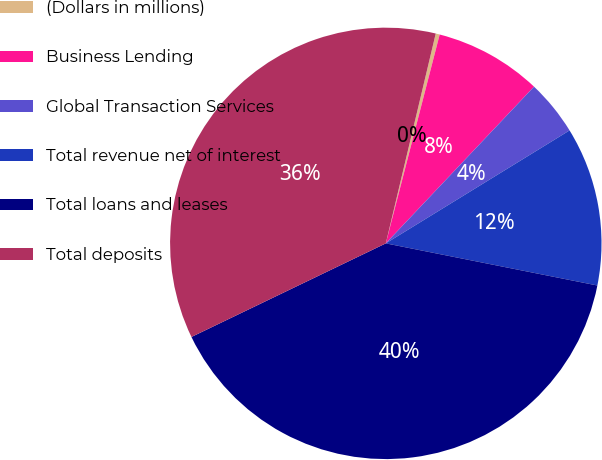Convert chart to OTSL. <chart><loc_0><loc_0><loc_500><loc_500><pie_chart><fcel>(Dollars in millions)<fcel>Business Lending<fcel>Global Transaction Services<fcel>Total revenue net of interest<fcel>Total loans and leases<fcel>Total deposits<nl><fcel>0.3%<fcel>8.04%<fcel>4.17%<fcel>11.9%<fcel>39.73%<fcel>35.86%<nl></chart> 